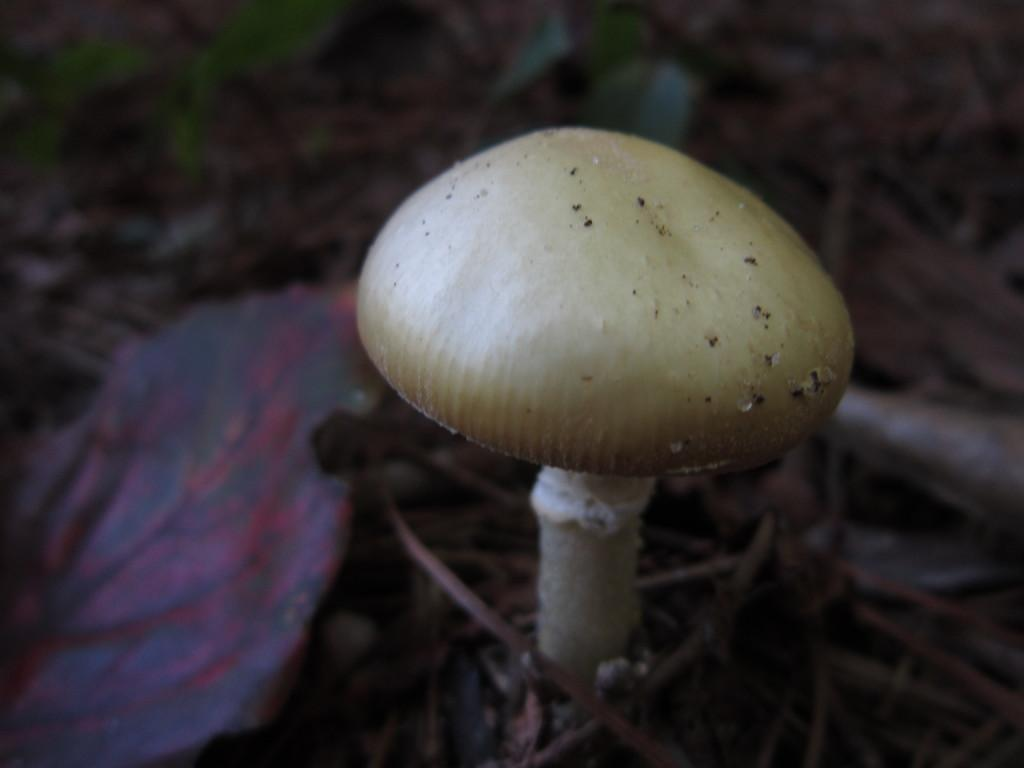What type of plant is visible in the image? There is a mushroom and a leaf in the image. Can you describe the background of the image? The background appears blurry. What type of pen is being used to write on the jam in the image? There is no pen or jam present in the image; it only features a mushroom and a leaf. 